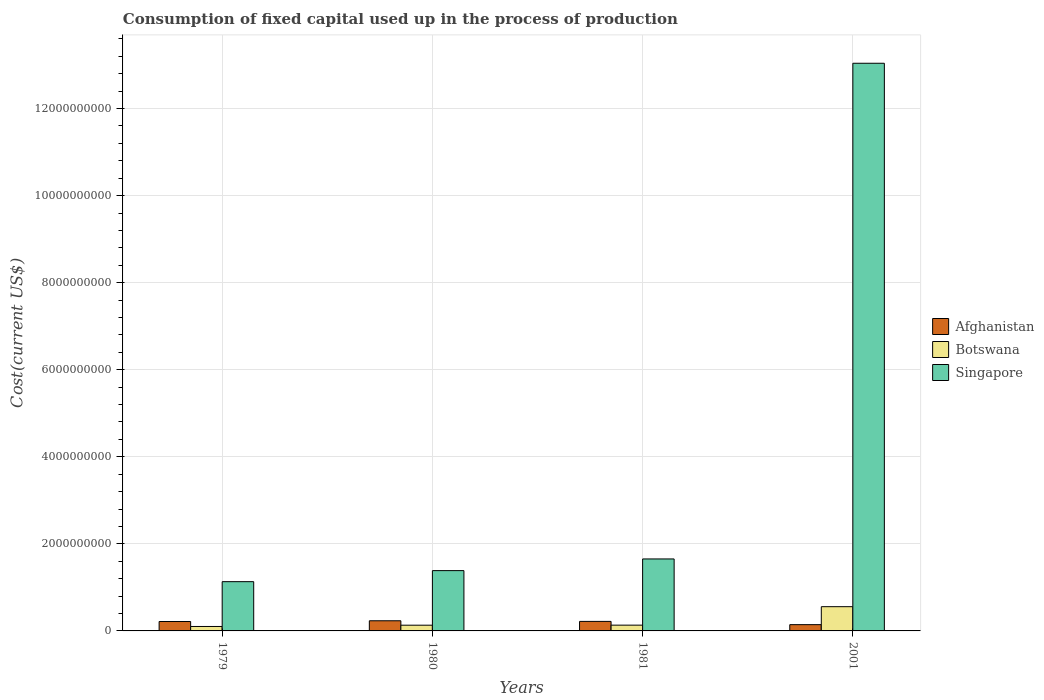How many bars are there on the 3rd tick from the left?
Your answer should be very brief. 3. How many bars are there on the 3rd tick from the right?
Your answer should be very brief. 3. What is the amount consumed in the process of production in Afghanistan in 1981?
Your response must be concise. 2.19e+08. Across all years, what is the maximum amount consumed in the process of production in Afghanistan?
Make the answer very short. 2.33e+08. Across all years, what is the minimum amount consumed in the process of production in Botswana?
Your response must be concise. 1.02e+08. In which year was the amount consumed in the process of production in Singapore maximum?
Give a very brief answer. 2001. In which year was the amount consumed in the process of production in Afghanistan minimum?
Your answer should be compact. 2001. What is the total amount consumed in the process of production in Singapore in the graph?
Your answer should be compact. 1.72e+1. What is the difference between the amount consumed in the process of production in Botswana in 1979 and that in 1980?
Your answer should be compact. -2.93e+07. What is the difference between the amount consumed in the process of production in Singapore in 2001 and the amount consumed in the process of production in Botswana in 1980?
Your answer should be very brief. 1.29e+1. What is the average amount consumed in the process of production in Botswana per year?
Provide a succinct answer. 2.31e+08. In the year 2001, what is the difference between the amount consumed in the process of production in Afghanistan and amount consumed in the process of production in Botswana?
Make the answer very short. -4.13e+08. In how many years, is the amount consumed in the process of production in Afghanistan greater than 2800000000 US$?
Your answer should be very brief. 0. What is the ratio of the amount consumed in the process of production in Afghanistan in 1980 to that in 1981?
Your answer should be compact. 1.07. What is the difference between the highest and the second highest amount consumed in the process of production in Botswana?
Keep it short and to the point. 4.24e+08. What is the difference between the highest and the lowest amount consumed in the process of production in Singapore?
Offer a terse response. 1.19e+1. Is the sum of the amount consumed in the process of production in Botswana in 1981 and 2001 greater than the maximum amount consumed in the process of production in Singapore across all years?
Offer a very short reply. No. What does the 2nd bar from the left in 1979 represents?
Offer a terse response. Botswana. What does the 3rd bar from the right in 2001 represents?
Offer a very short reply. Afghanistan. Is it the case that in every year, the sum of the amount consumed in the process of production in Afghanistan and amount consumed in the process of production in Singapore is greater than the amount consumed in the process of production in Botswana?
Offer a very short reply. Yes. How many bars are there?
Offer a terse response. 12. How many years are there in the graph?
Offer a very short reply. 4. Are the values on the major ticks of Y-axis written in scientific E-notation?
Provide a succinct answer. No. Does the graph contain grids?
Offer a very short reply. Yes. How are the legend labels stacked?
Ensure brevity in your answer.  Vertical. What is the title of the graph?
Provide a short and direct response. Consumption of fixed capital used up in the process of production. What is the label or title of the Y-axis?
Give a very brief answer. Cost(current US$). What is the Cost(current US$) in Afghanistan in 1979?
Ensure brevity in your answer.  2.16e+08. What is the Cost(current US$) in Botswana in 1979?
Ensure brevity in your answer.  1.02e+08. What is the Cost(current US$) of Singapore in 1979?
Give a very brief answer. 1.13e+09. What is the Cost(current US$) of Afghanistan in 1980?
Make the answer very short. 2.33e+08. What is the Cost(current US$) in Botswana in 1980?
Ensure brevity in your answer.  1.31e+08. What is the Cost(current US$) in Singapore in 1980?
Your response must be concise. 1.39e+09. What is the Cost(current US$) of Afghanistan in 1981?
Ensure brevity in your answer.  2.19e+08. What is the Cost(current US$) of Botswana in 1981?
Offer a very short reply. 1.32e+08. What is the Cost(current US$) of Singapore in 1981?
Give a very brief answer. 1.65e+09. What is the Cost(current US$) in Afghanistan in 2001?
Provide a succinct answer. 1.44e+08. What is the Cost(current US$) of Botswana in 2001?
Your answer should be compact. 5.57e+08. What is the Cost(current US$) in Singapore in 2001?
Give a very brief answer. 1.30e+1. Across all years, what is the maximum Cost(current US$) of Afghanistan?
Give a very brief answer. 2.33e+08. Across all years, what is the maximum Cost(current US$) in Botswana?
Provide a short and direct response. 5.57e+08. Across all years, what is the maximum Cost(current US$) of Singapore?
Provide a short and direct response. 1.30e+1. Across all years, what is the minimum Cost(current US$) of Afghanistan?
Ensure brevity in your answer.  1.44e+08. Across all years, what is the minimum Cost(current US$) in Botswana?
Offer a terse response. 1.02e+08. Across all years, what is the minimum Cost(current US$) of Singapore?
Provide a short and direct response. 1.13e+09. What is the total Cost(current US$) of Afghanistan in the graph?
Offer a terse response. 8.12e+08. What is the total Cost(current US$) in Botswana in the graph?
Your answer should be compact. 9.23e+08. What is the total Cost(current US$) in Singapore in the graph?
Your answer should be compact. 1.72e+1. What is the difference between the Cost(current US$) in Afghanistan in 1979 and that in 1980?
Keep it short and to the point. -1.68e+07. What is the difference between the Cost(current US$) of Botswana in 1979 and that in 1980?
Your response must be concise. -2.93e+07. What is the difference between the Cost(current US$) in Singapore in 1979 and that in 1980?
Your answer should be compact. -2.54e+08. What is the difference between the Cost(current US$) in Afghanistan in 1979 and that in 1981?
Offer a terse response. -2.39e+06. What is the difference between the Cost(current US$) of Botswana in 1979 and that in 1981?
Keep it short and to the point. -3.03e+07. What is the difference between the Cost(current US$) of Singapore in 1979 and that in 1981?
Make the answer very short. -5.22e+08. What is the difference between the Cost(current US$) of Afghanistan in 1979 and that in 2001?
Provide a succinct answer. 7.21e+07. What is the difference between the Cost(current US$) in Botswana in 1979 and that in 2001?
Provide a succinct answer. -4.55e+08. What is the difference between the Cost(current US$) of Singapore in 1979 and that in 2001?
Provide a short and direct response. -1.19e+1. What is the difference between the Cost(current US$) of Afghanistan in 1980 and that in 1981?
Provide a short and direct response. 1.44e+07. What is the difference between the Cost(current US$) in Botswana in 1980 and that in 1981?
Your response must be concise. -1.05e+06. What is the difference between the Cost(current US$) of Singapore in 1980 and that in 1981?
Give a very brief answer. -2.68e+08. What is the difference between the Cost(current US$) of Afghanistan in 1980 and that in 2001?
Give a very brief answer. 8.89e+07. What is the difference between the Cost(current US$) of Botswana in 1980 and that in 2001?
Keep it short and to the point. -4.25e+08. What is the difference between the Cost(current US$) of Singapore in 1980 and that in 2001?
Your answer should be compact. -1.17e+1. What is the difference between the Cost(current US$) of Afghanistan in 1981 and that in 2001?
Your answer should be very brief. 7.45e+07. What is the difference between the Cost(current US$) in Botswana in 1981 and that in 2001?
Give a very brief answer. -4.24e+08. What is the difference between the Cost(current US$) in Singapore in 1981 and that in 2001?
Offer a very short reply. -1.14e+1. What is the difference between the Cost(current US$) in Afghanistan in 1979 and the Cost(current US$) in Botswana in 1980?
Offer a very short reply. 8.48e+07. What is the difference between the Cost(current US$) of Afghanistan in 1979 and the Cost(current US$) of Singapore in 1980?
Provide a short and direct response. -1.17e+09. What is the difference between the Cost(current US$) in Botswana in 1979 and the Cost(current US$) in Singapore in 1980?
Make the answer very short. -1.28e+09. What is the difference between the Cost(current US$) in Afghanistan in 1979 and the Cost(current US$) in Botswana in 1981?
Provide a succinct answer. 8.38e+07. What is the difference between the Cost(current US$) of Afghanistan in 1979 and the Cost(current US$) of Singapore in 1981?
Ensure brevity in your answer.  -1.44e+09. What is the difference between the Cost(current US$) of Botswana in 1979 and the Cost(current US$) of Singapore in 1981?
Your response must be concise. -1.55e+09. What is the difference between the Cost(current US$) in Afghanistan in 1979 and the Cost(current US$) in Botswana in 2001?
Provide a succinct answer. -3.41e+08. What is the difference between the Cost(current US$) in Afghanistan in 1979 and the Cost(current US$) in Singapore in 2001?
Your response must be concise. -1.28e+1. What is the difference between the Cost(current US$) in Botswana in 1979 and the Cost(current US$) in Singapore in 2001?
Provide a succinct answer. -1.29e+1. What is the difference between the Cost(current US$) in Afghanistan in 1980 and the Cost(current US$) in Botswana in 1981?
Offer a terse response. 1.01e+08. What is the difference between the Cost(current US$) of Afghanistan in 1980 and the Cost(current US$) of Singapore in 1981?
Offer a terse response. -1.42e+09. What is the difference between the Cost(current US$) of Botswana in 1980 and the Cost(current US$) of Singapore in 1981?
Provide a succinct answer. -1.52e+09. What is the difference between the Cost(current US$) in Afghanistan in 1980 and the Cost(current US$) in Botswana in 2001?
Your answer should be compact. -3.24e+08. What is the difference between the Cost(current US$) in Afghanistan in 1980 and the Cost(current US$) in Singapore in 2001?
Offer a terse response. -1.28e+1. What is the difference between the Cost(current US$) in Botswana in 1980 and the Cost(current US$) in Singapore in 2001?
Offer a very short reply. -1.29e+1. What is the difference between the Cost(current US$) of Afghanistan in 1981 and the Cost(current US$) of Botswana in 2001?
Your answer should be compact. -3.38e+08. What is the difference between the Cost(current US$) in Afghanistan in 1981 and the Cost(current US$) in Singapore in 2001?
Offer a terse response. -1.28e+1. What is the difference between the Cost(current US$) in Botswana in 1981 and the Cost(current US$) in Singapore in 2001?
Ensure brevity in your answer.  -1.29e+1. What is the average Cost(current US$) of Afghanistan per year?
Give a very brief answer. 2.03e+08. What is the average Cost(current US$) in Botswana per year?
Provide a succinct answer. 2.31e+08. What is the average Cost(current US$) in Singapore per year?
Offer a terse response. 4.30e+09. In the year 1979, what is the difference between the Cost(current US$) in Afghanistan and Cost(current US$) in Botswana?
Your answer should be very brief. 1.14e+08. In the year 1979, what is the difference between the Cost(current US$) in Afghanistan and Cost(current US$) in Singapore?
Make the answer very short. -9.15e+08. In the year 1979, what is the difference between the Cost(current US$) in Botswana and Cost(current US$) in Singapore?
Your answer should be very brief. -1.03e+09. In the year 1980, what is the difference between the Cost(current US$) of Afghanistan and Cost(current US$) of Botswana?
Make the answer very short. 1.02e+08. In the year 1980, what is the difference between the Cost(current US$) of Afghanistan and Cost(current US$) of Singapore?
Keep it short and to the point. -1.15e+09. In the year 1980, what is the difference between the Cost(current US$) of Botswana and Cost(current US$) of Singapore?
Offer a terse response. -1.25e+09. In the year 1981, what is the difference between the Cost(current US$) in Afghanistan and Cost(current US$) in Botswana?
Give a very brief answer. 8.62e+07. In the year 1981, what is the difference between the Cost(current US$) of Afghanistan and Cost(current US$) of Singapore?
Make the answer very short. -1.43e+09. In the year 1981, what is the difference between the Cost(current US$) of Botswana and Cost(current US$) of Singapore?
Offer a very short reply. -1.52e+09. In the year 2001, what is the difference between the Cost(current US$) of Afghanistan and Cost(current US$) of Botswana?
Ensure brevity in your answer.  -4.13e+08. In the year 2001, what is the difference between the Cost(current US$) of Afghanistan and Cost(current US$) of Singapore?
Give a very brief answer. -1.29e+1. In the year 2001, what is the difference between the Cost(current US$) in Botswana and Cost(current US$) in Singapore?
Provide a succinct answer. -1.25e+1. What is the ratio of the Cost(current US$) of Afghanistan in 1979 to that in 1980?
Provide a short and direct response. 0.93. What is the ratio of the Cost(current US$) of Botswana in 1979 to that in 1980?
Your answer should be compact. 0.78. What is the ratio of the Cost(current US$) of Singapore in 1979 to that in 1980?
Offer a terse response. 0.82. What is the ratio of the Cost(current US$) in Afghanistan in 1979 to that in 1981?
Offer a very short reply. 0.99. What is the ratio of the Cost(current US$) of Botswana in 1979 to that in 1981?
Give a very brief answer. 0.77. What is the ratio of the Cost(current US$) of Singapore in 1979 to that in 1981?
Give a very brief answer. 0.68. What is the ratio of the Cost(current US$) in Afghanistan in 1979 to that in 2001?
Your response must be concise. 1.5. What is the ratio of the Cost(current US$) of Botswana in 1979 to that in 2001?
Provide a succinct answer. 0.18. What is the ratio of the Cost(current US$) of Singapore in 1979 to that in 2001?
Offer a very short reply. 0.09. What is the ratio of the Cost(current US$) of Afghanistan in 1980 to that in 1981?
Ensure brevity in your answer.  1.07. What is the ratio of the Cost(current US$) in Singapore in 1980 to that in 1981?
Give a very brief answer. 0.84. What is the ratio of the Cost(current US$) in Afghanistan in 1980 to that in 2001?
Give a very brief answer. 1.62. What is the ratio of the Cost(current US$) of Botswana in 1980 to that in 2001?
Keep it short and to the point. 0.24. What is the ratio of the Cost(current US$) of Singapore in 1980 to that in 2001?
Keep it short and to the point. 0.11. What is the ratio of the Cost(current US$) of Afghanistan in 1981 to that in 2001?
Keep it short and to the point. 1.52. What is the ratio of the Cost(current US$) in Botswana in 1981 to that in 2001?
Provide a succinct answer. 0.24. What is the ratio of the Cost(current US$) of Singapore in 1981 to that in 2001?
Provide a short and direct response. 0.13. What is the difference between the highest and the second highest Cost(current US$) in Afghanistan?
Provide a short and direct response. 1.44e+07. What is the difference between the highest and the second highest Cost(current US$) of Botswana?
Your answer should be compact. 4.24e+08. What is the difference between the highest and the second highest Cost(current US$) in Singapore?
Your answer should be very brief. 1.14e+1. What is the difference between the highest and the lowest Cost(current US$) in Afghanistan?
Provide a succinct answer. 8.89e+07. What is the difference between the highest and the lowest Cost(current US$) in Botswana?
Ensure brevity in your answer.  4.55e+08. What is the difference between the highest and the lowest Cost(current US$) of Singapore?
Keep it short and to the point. 1.19e+1. 